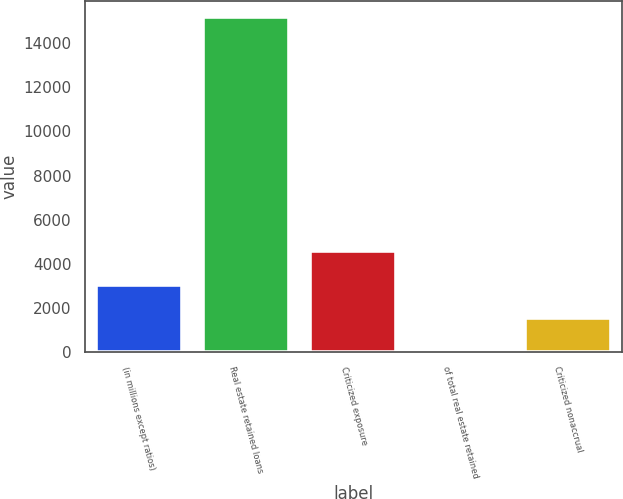<chart> <loc_0><loc_0><loc_500><loc_500><bar_chart><fcel>(in millions except ratios)<fcel>Real estate retained loans<fcel>Criticized exposure<fcel>of total real estate retained<fcel>Criticized nonaccrual<nl><fcel>3054.33<fcel>15170<fcel>4568.79<fcel>25.41<fcel>1539.87<nl></chart> 